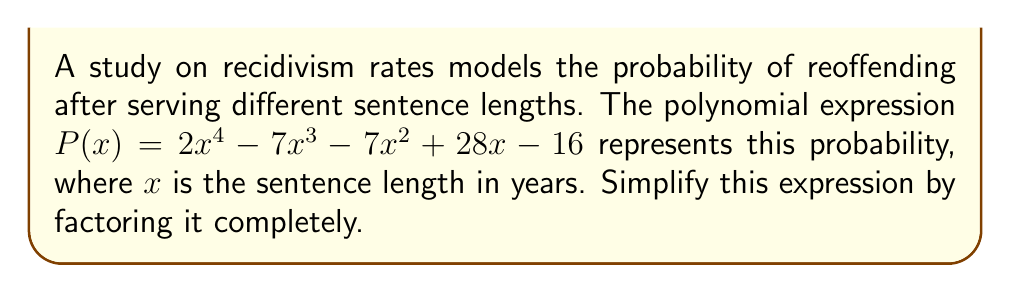Give your solution to this math problem. Let's approach this step-by-step:

1) First, we can check if there are any common factors. In this case, there are none.

2) Next, we can try the rational root theorem. The possible rational roots are the factors of the constant term: ±1, ±2, ±4, ±8, ±16.

3) Testing these, we find that $x = 1$ and $x = 2$ are roots.

4) We can factor out $(x-1)$ and $(x-2)$:

   $P(x) = (x-1)(x-2)(2x^2 - 3x - 8)$

5) Now we need to factor the quadratic term $2x^2 - 3x - 8$:

   a) The leading coefficient is 2, so we look for factors of $2 \cdot (-8) = -16$ that add up to -3.
   b) We find that $1$ and $-4$ work: $1 + (-4) = -3$ and $1 \cdot (-4) = -4$.

6) Therefore, we can factor the quadratic as:

   $2x^2 - 3x - 8 = (2x+1)(x-4)$

7) Putting it all together:

   $P(x) = (x-1)(x-2)(2x+1)(x-4)$

This is the fully factored form of the polynomial.
Answer: $(x-1)(x-2)(2x+1)(x-4)$ 